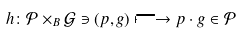<formula> <loc_0><loc_0><loc_500><loc_500>h \colon \mathcal { P } \times _ { B } \mathcal { G } \ni ( p , g ) \longmapsto p \cdot g \in \mathcal { P }</formula> 